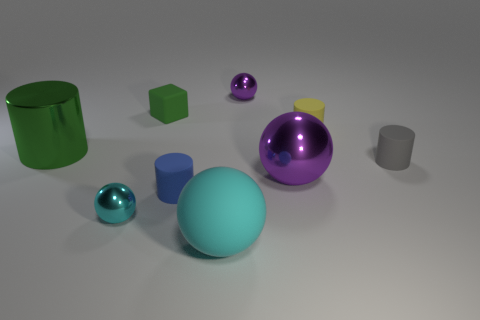What size is the other shiny thing that is the same shape as the small blue thing?
Your answer should be very brief. Large. What number of tiny blocks have the same color as the big cylinder?
Provide a succinct answer. 1. Is the number of tiny blue matte cylinders greater than the number of large blue metallic blocks?
Your response must be concise. Yes. Is there a small green object that has the same shape as the gray thing?
Provide a short and direct response. No. There is a large object that is on the right side of the large matte object; what is its shape?
Ensure brevity in your answer.  Sphere. There is a tiny metallic object that is on the right side of the small cyan metallic ball to the left of the small yellow rubber thing; what number of purple objects are on the right side of it?
Offer a very short reply. 1. There is a tiny sphere that is in front of the big purple object; is its color the same as the big matte ball?
Provide a succinct answer. Yes. What number of other things are the same shape as the small blue rubber thing?
Offer a terse response. 3. How many other objects are the same material as the tiny yellow object?
Make the answer very short. 4. What is the material of the large ball that is to the left of the large sphere behind the tiny matte cylinder that is on the left side of the tiny purple metal sphere?
Make the answer very short. Rubber. 